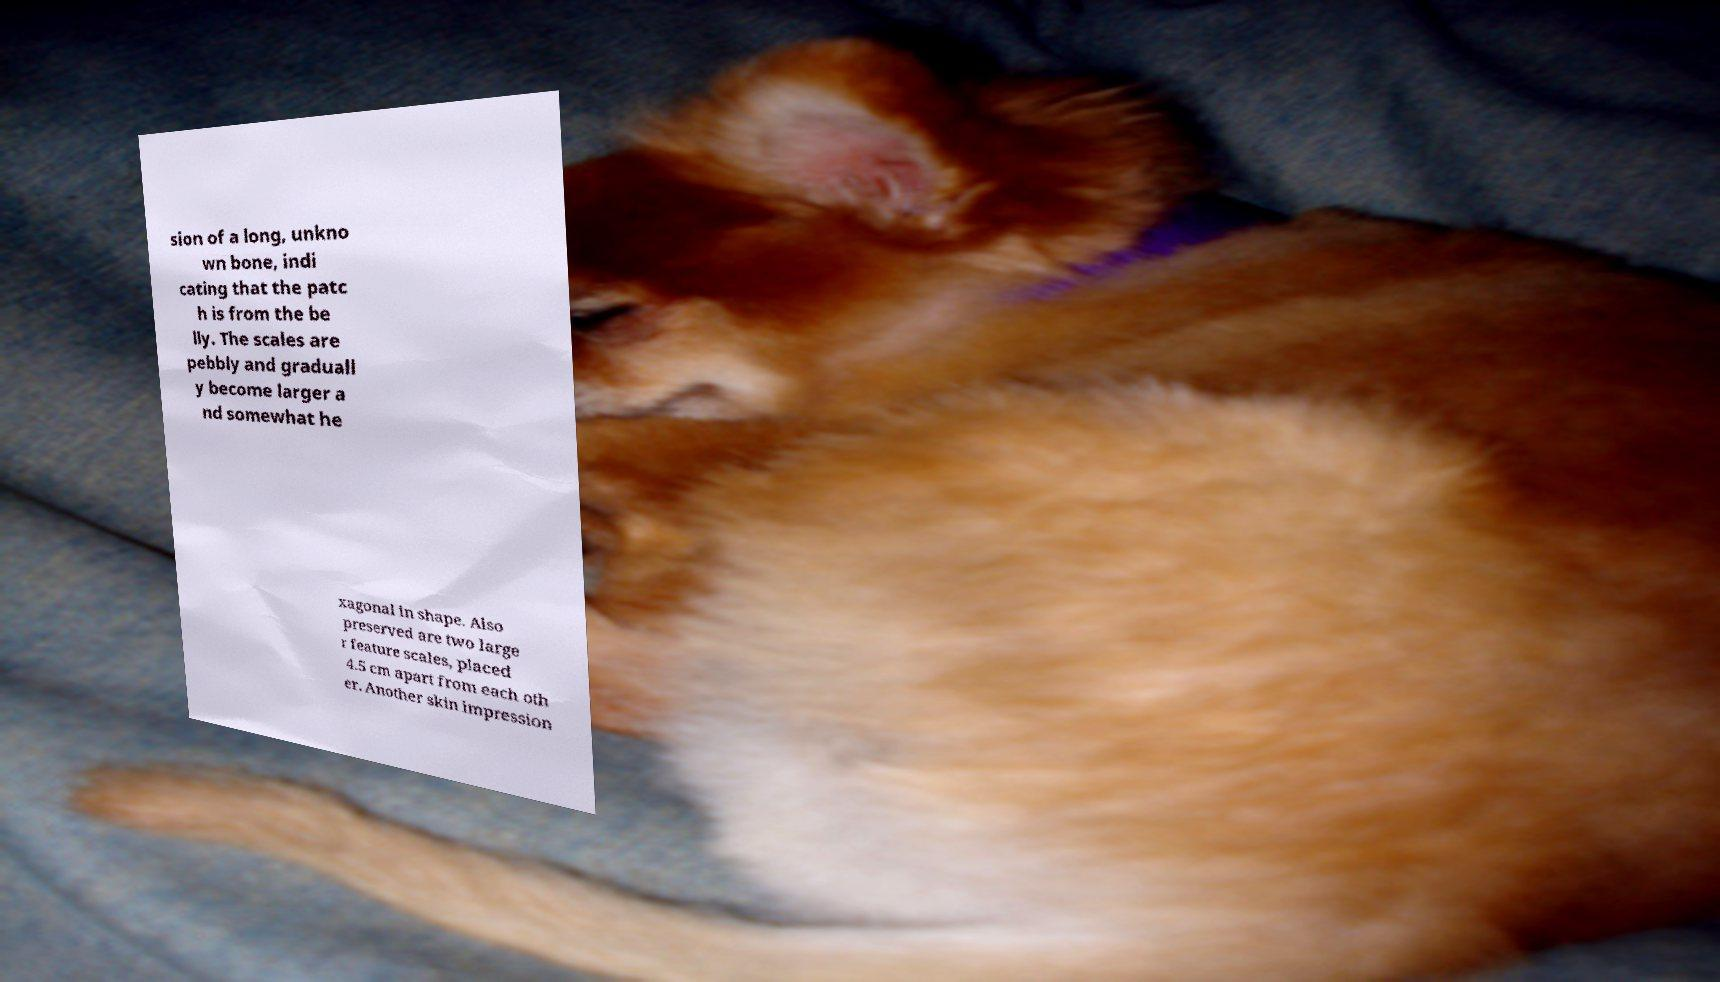Can you read and provide the text displayed in the image?This photo seems to have some interesting text. Can you extract and type it out for me? sion of a long, unkno wn bone, indi cating that the patc h is from the be lly. The scales are pebbly and graduall y become larger a nd somewhat he xagonal in shape. Also preserved are two large r feature scales, placed 4.5 cm apart from each oth er. Another skin impression 